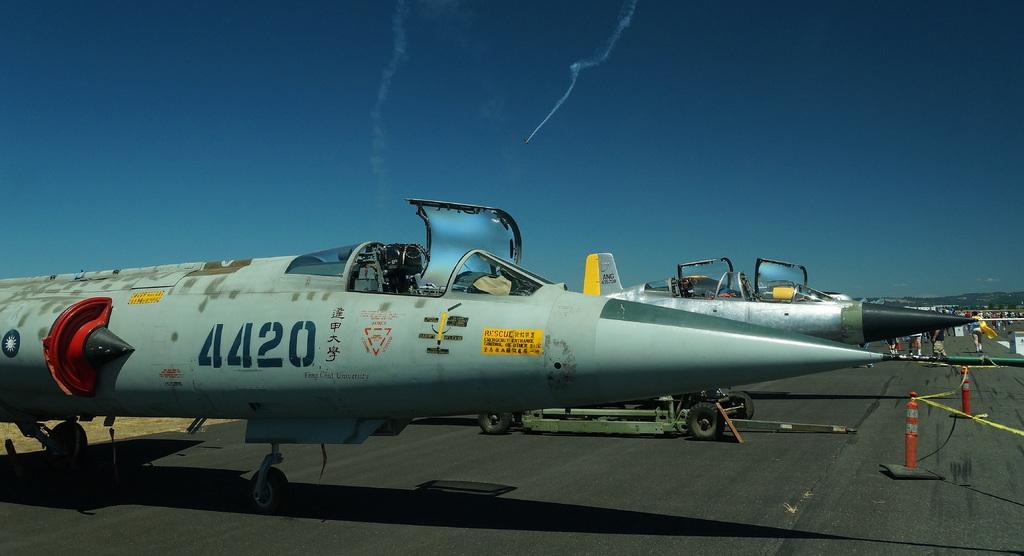In one or two sentences, can you explain what this image depicts? In this image we can see aircraft. In the back there are few people. On the aircraft we can see text, sign and numbers. In the background there is sky. On the right side there are traffic cones and ropes. 